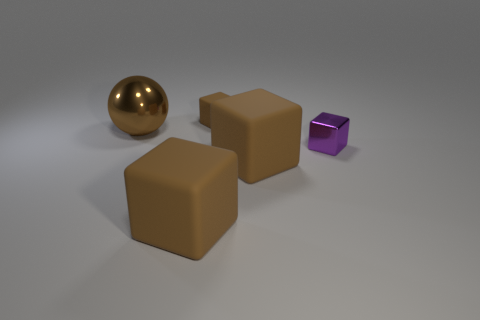Are there any large brown things behind the brown rubber cube behind the shiny thing that is left of the tiny purple metallic block?
Your answer should be very brief. No. There is a metallic ball that is the same color as the tiny matte thing; what size is it?
Make the answer very short. Large. There is a small purple thing; are there any tiny shiny cubes on the right side of it?
Ensure brevity in your answer.  No. What number of other things are the same shape as the purple thing?
Provide a short and direct response. 3. The matte object that is the same size as the purple metal block is what color?
Make the answer very short. Brown. Is the number of brown cubes that are in front of the shiny block less than the number of large objects in front of the tiny brown cube?
Provide a short and direct response. Yes. What number of big brown things are behind the small metallic cube that is to the right of the big brown object that is behind the purple thing?
Offer a terse response. 1. Are there fewer large brown blocks that are behind the large brown metal thing than small blue cylinders?
Offer a very short reply. No. Do the tiny brown rubber thing and the large metallic thing have the same shape?
Offer a terse response. No. The other tiny rubber thing that is the same shape as the purple thing is what color?
Offer a very short reply. Brown. 